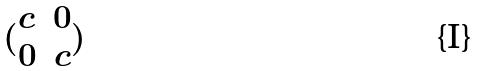Convert formula to latex. <formula><loc_0><loc_0><loc_500><loc_500>( \begin{matrix} c & 0 \\ 0 & c \end{matrix} )</formula> 